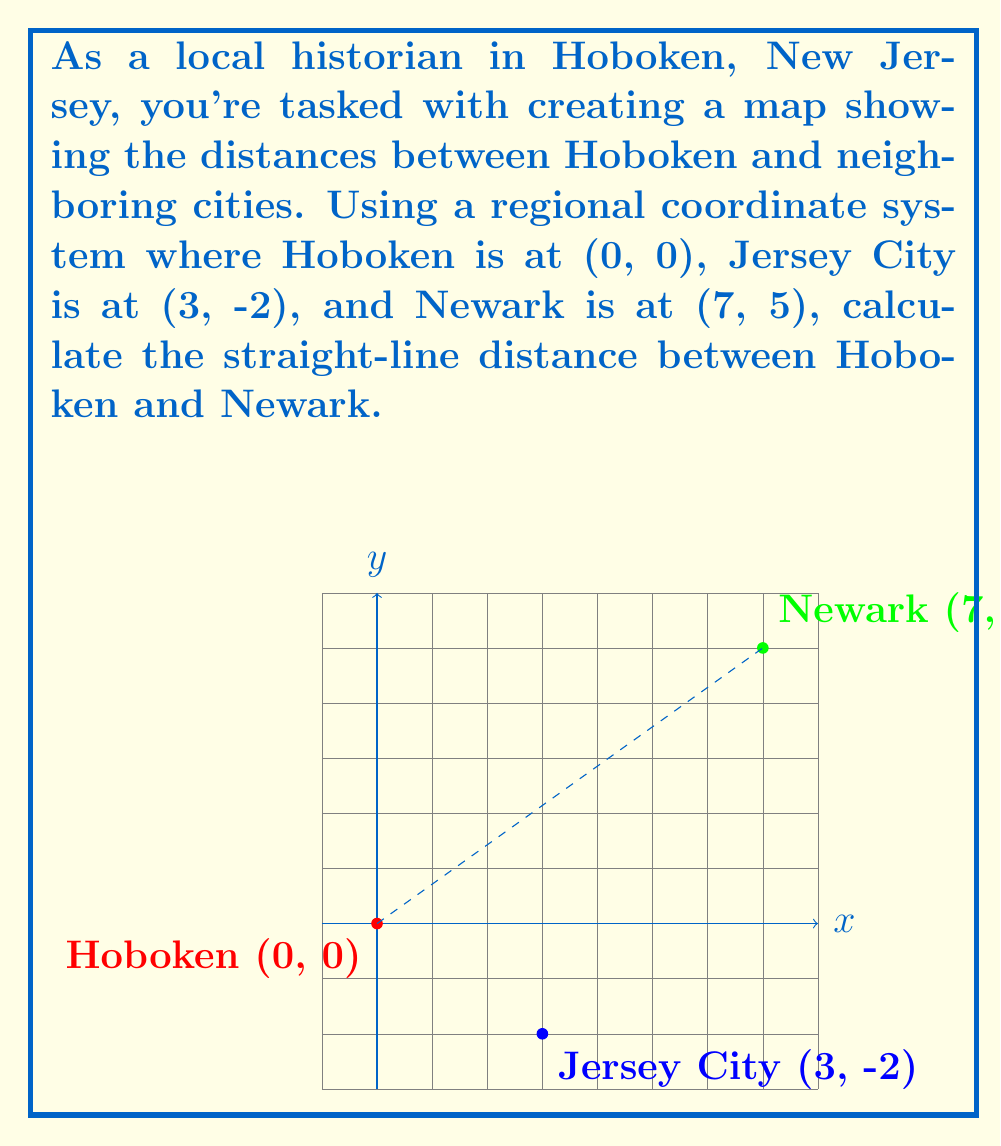Teach me how to tackle this problem. To find the distance between two points in a coordinate system, we use the distance formula:

$$d = \sqrt{(x_2 - x_1)^2 + (y_2 - y_1)^2}$$

Where $(x_1, y_1)$ is the first point and $(x_2, y_2)$ is the second point.

For Hoboken: $(x_1, y_1) = (0, 0)$
For Newark: $(x_2, y_2) = (7, 5)$

Plugging these values into the formula:

$$d = \sqrt{(7 - 0)^2 + (5 - 0)^2}$$

Simplify:
$$d = \sqrt{7^2 + 5^2}$$
$$d = \sqrt{49 + 25}$$
$$d = \sqrt{74}$$

The square root of 74 cannot be simplified further, so we leave it in this form or calculate its decimal approximation:

$$d \approx 8.602$$

Therefore, the straight-line distance between Hoboken and Newark in this coordinate system is $\sqrt{74}$ units, or approximately 8.602 units.
Answer: $\sqrt{74}$ units 